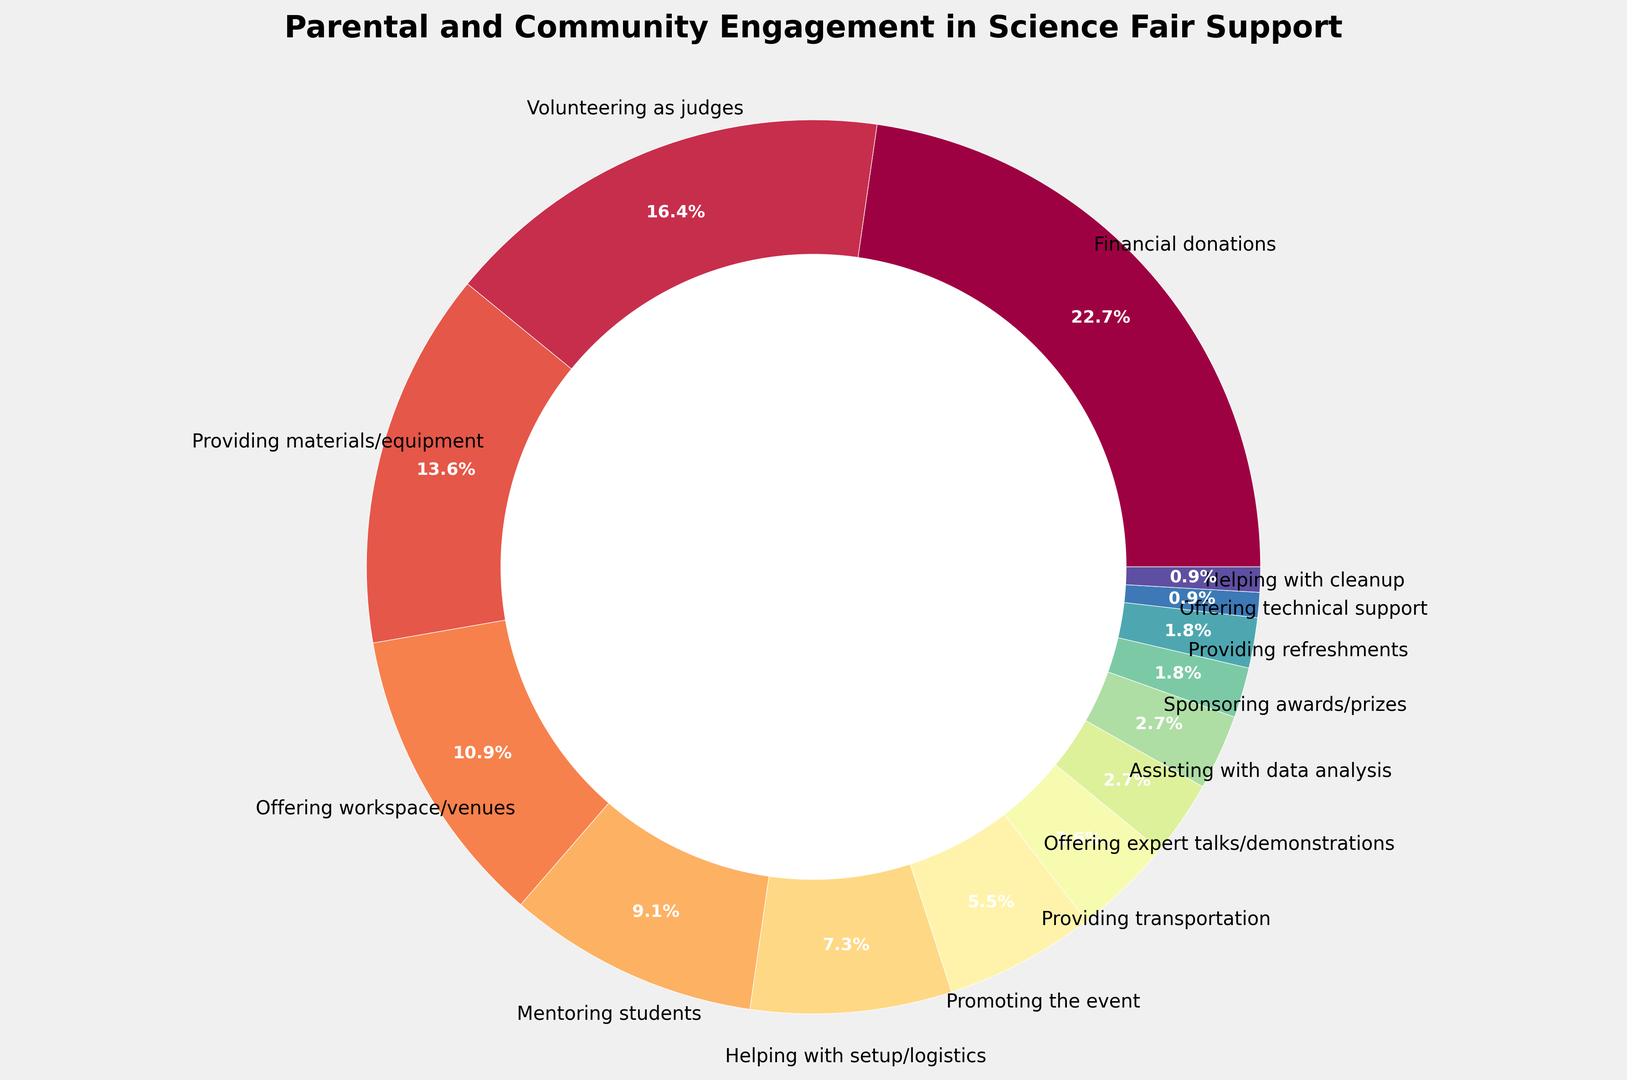What percentage of support does volunteering as judges represent? The ring chart shows that "Volunteering as judges" represents 18% of the total support.
Answer: 18% Which type of support is lower, providing refreshments or helping with cleanup? By observing the chart, "Providing refreshments" and "Helping with cleanup" both have a ring sector, but "Providing refreshments" is 2%, whereas "Helping with cleanup" is 1%.
Answer: Helping with cleanup What is the total percentage of support for mentoring students and providing materials/equipment? The ring chart shows "Mentoring students" at 10% and "Providing materials/equipment" at 15%. Adding these gives 10 + 15 = 25.
Answer: 25% Which two types of support have the same percentage? "Assisting with data analysis" and "Offering expert talks/demonstrations" both show a percentage of 3% each.
Answer: Assisting with data analysis and Offering expert talks/demonstrations Out of financial donations and promoting the event, which type of support is more common? "Financial donations" occupies a larger portion at 25% compared to "Promoting the event" which is at 6%.
Answer: Financial donations What's the difference between the percentage of support for financial donations and volunteering as judges? The chart indicates "Financial donations" at 25% and "Volunteering as judges" at 18%. The difference is 25 - 18 = 7.
Answer: 7% What's the proportion of technical support compared to mentoring students? "Offering technical support" is at 1%, while "Mentoring students" is at 10%. The proportion is 1/10.
Answer: 1/10 What is the sum of the least common support types? The chart shows the least common supports are "Offering technical support" and "Helping with cleanup," both at 1%. Adding these amounts to 1 + 1 = 2.
Answer: 2% Which color represents providing materials/equipment? In the ring chart, each type of support is represented by a different color. The color corresponding to "Providing materials/equipment" can be identified visually.
Answer: [User to observe the chart for the specific color] How much more common is providing materials/equipment than providing transportation? “Providing materials/equipment” is at 15% while “Providing transportation” is at 4%. The difference is 15 - 4 = 11.
Answer: 11 